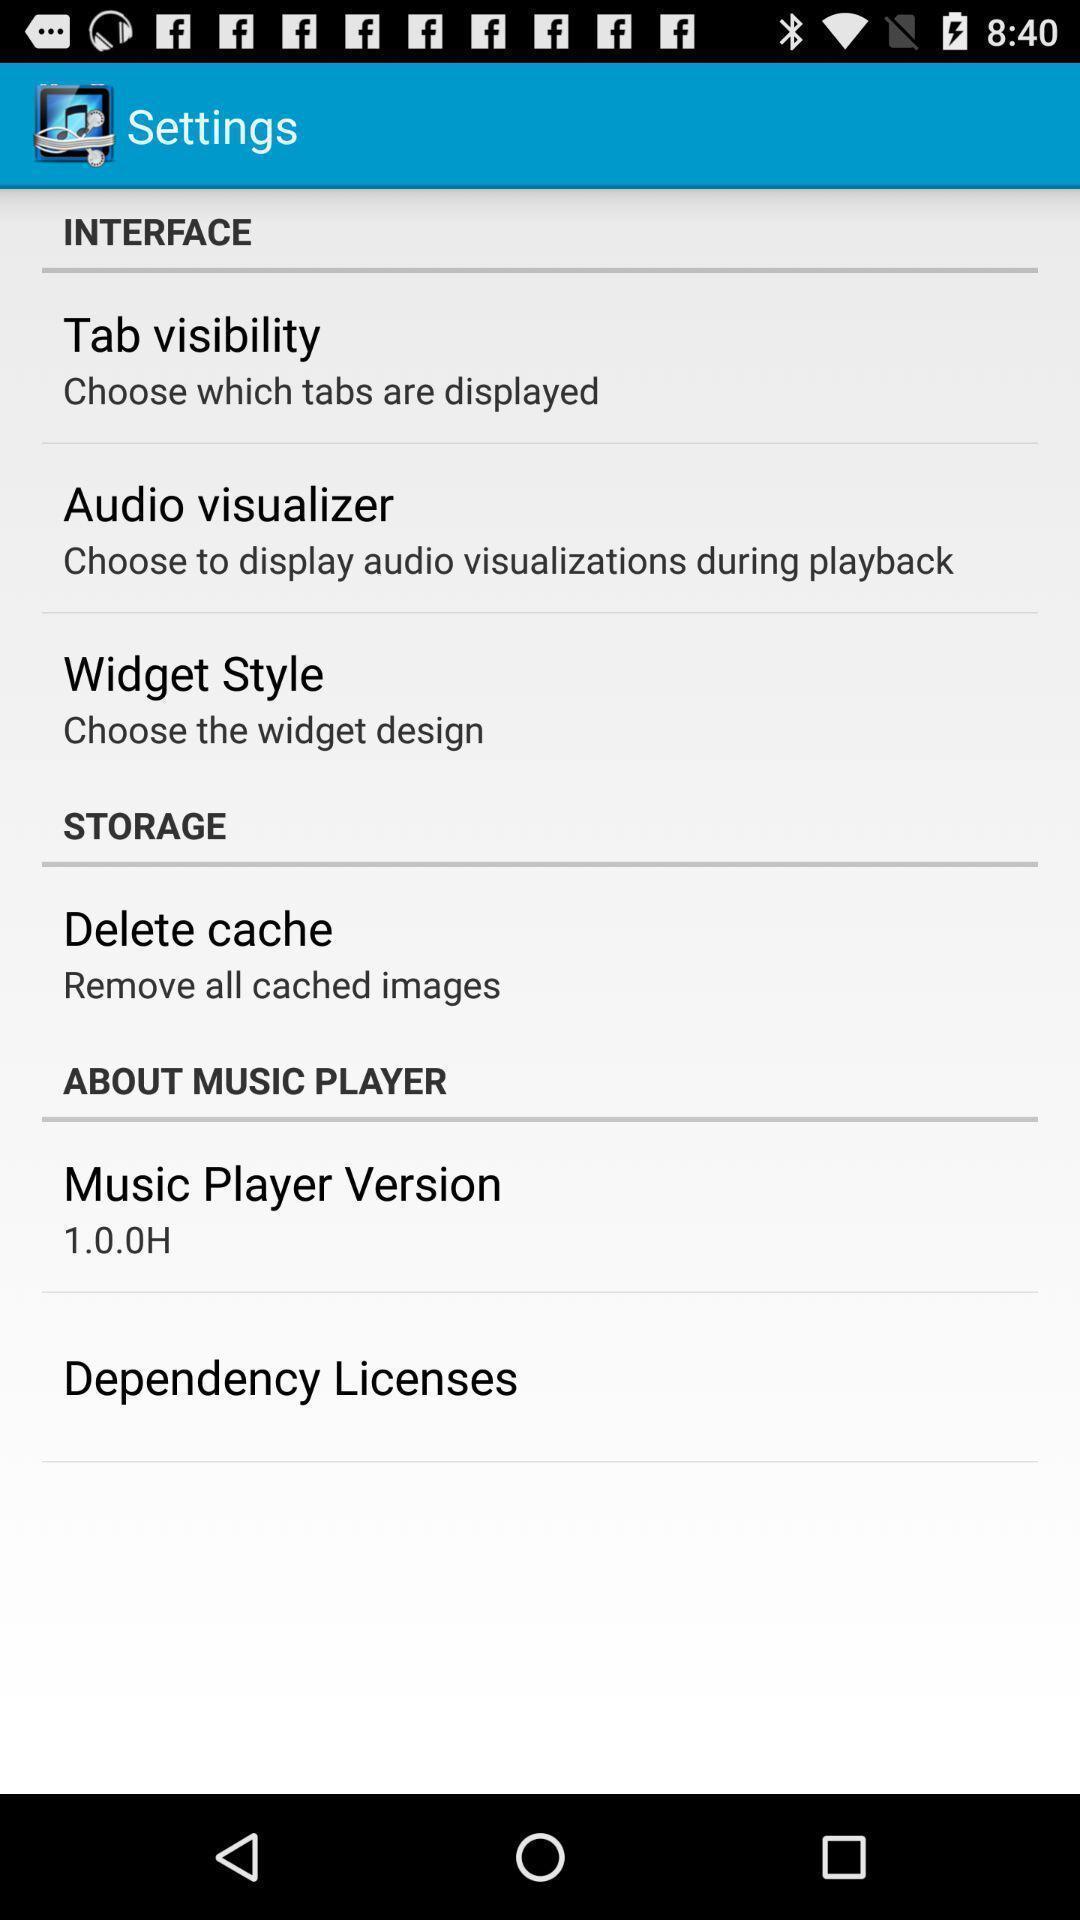What is the overall content of this screenshot? Settings page in a music app. 